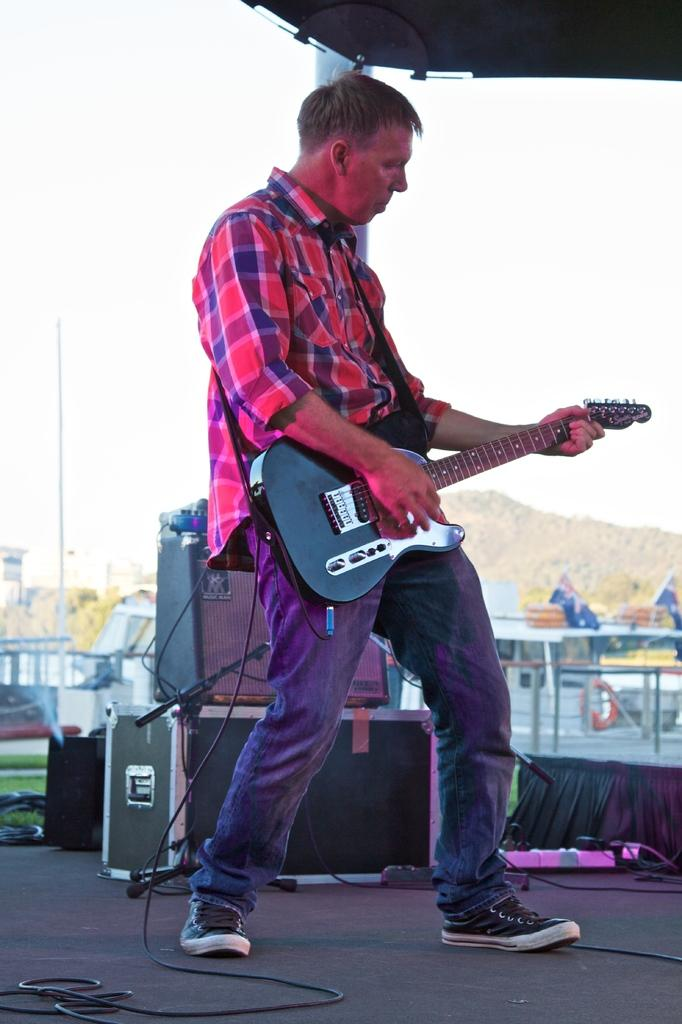Who is the main subject in the image? There is a man in the image. What is the man holding in the image? The man is holding a guitar. What can be seen in the background of the image? There are equipment and wires in the background of the image. What type of produce is being sold in the lunchroom in the image? There is no lunchroom or produce present in the image. 